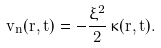Convert formula to latex. <formula><loc_0><loc_0><loc_500><loc_500>v _ { n } ( { r } , t ) = - \frac { \xi ^ { 2 } } { 2 } \, \kappa ( { r } , t ) .</formula> 